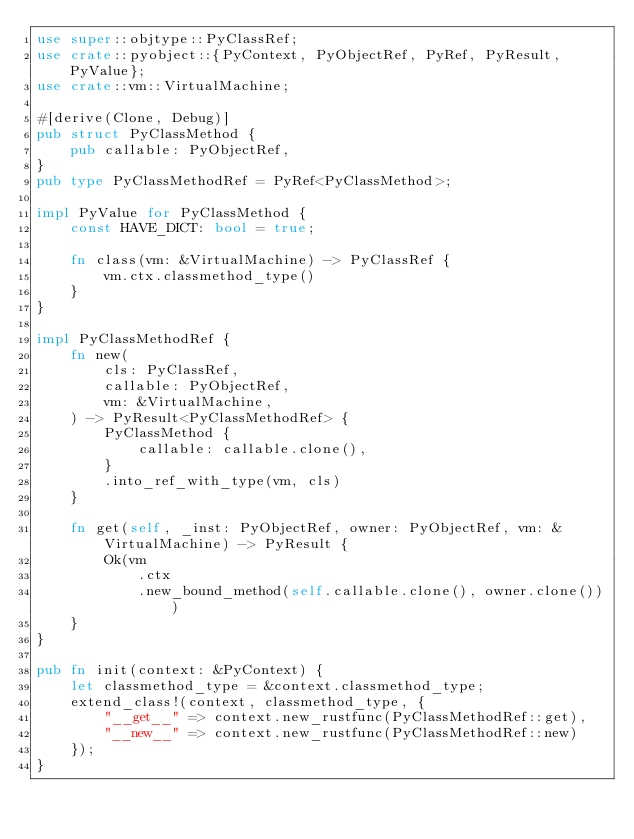Convert code to text. <code><loc_0><loc_0><loc_500><loc_500><_Rust_>use super::objtype::PyClassRef;
use crate::pyobject::{PyContext, PyObjectRef, PyRef, PyResult, PyValue};
use crate::vm::VirtualMachine;

#[derive(Clone, Debug)]
pub struct PyClassMethod {
    pub callable: PyObjectRef,
}
pub type PyClassMethodRef = PyRef<PyClassMethod>;

impl PyValue for PyClassMethod {
    const HAVE_DICT: bool = true;

    fn class(vm: &VirtualMachine) -> PyClassRef {
        vm.ctx.classmethod_type()
    }
}

impl PyClassMethodRef {
    fn new(
        cls: PyClassRef,
        callable: PyObjectRef,
        vm: &VirtualMachine,
    ) -> PyResult<PyClassMethodRef> {
        PyClassMethod {
            callable: callable.clone(),
        }
        .into_ref_with_type(vm, cls)
    }

    fn get(self, _inst: PyObjectRef, owner: PyObjectRef, vm: &VirtualMachine) -> PyResult {
        Ok(vm
            .ctx
            .new_bound_method(self.callable.clone(), owner.clone()))
    }
}

pub fn init(context: &PyContext) {
    let classmethod_type = &context.classmethod_type;
    extend_class!(context, classmethod_type, {
        "__get__" => context.new_rustfunc(PyClassMethodRef::get),
        "__new__" => context.new_rustfunc(PyClassMethodRef::new)
    });
}
</code> 